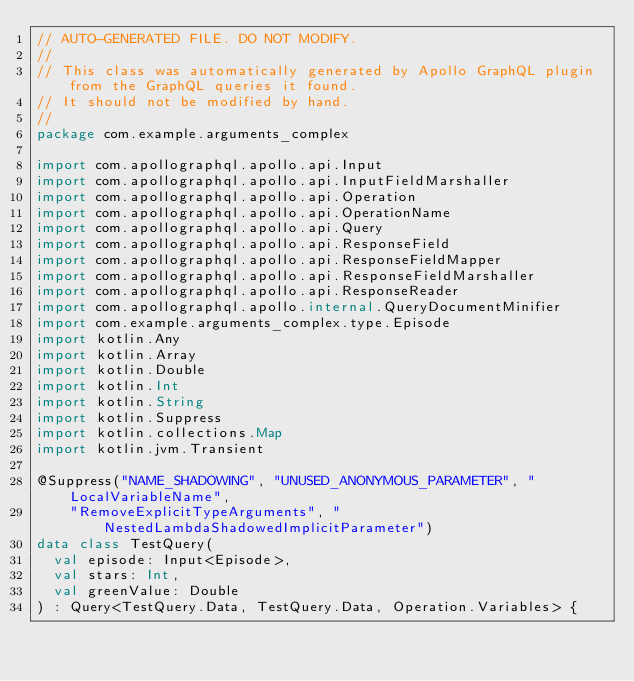Convert code to text. <code><loc_0><loc_0><loc_500><loc_500><_Kotlin_>// AUTO-GENERATED FILE. DO NOT MODIFY.
//
// This class was automatically generated by Apollo GraphQL plugin from the GraphQL queries it found.
// It should not be modified by hand.
//
package com.example.arguments_complex

import com.apollographql.apollo.api.Input
import com.apollographql.apollo.api.InputFieldMarshaller
import com.apollographql.apollo.api.Operation
import com.apollographql.apollo.api.OperationName
import com.apollographql.apollo.api.Query
import com.apollographql.apollo.api.ResponseField
import com.apollographql.apollo.api.ResponseFieldMapper
import com.apollographql.apollo.api.ResponseFieldMarshaller
import com.apollographql.apollo.api.ResponseReader
import com.apollographql.apollo.internal.QueryDocumentMinifier
import com.example.arguments_complex.type.Episode
import kotlin.Any
import kotlin.Array
import kotlin.Double
import kotlin.Int
import kotlin.String
import kotlin.Suppress
import kotlin.collections.Map
import kotlin.jvm.Transient

@Suppress("NAME_SHADOWING", "UNUSED_ANONYMOUS_PARAMETER", "LocalVariableName",
    "RemoveExplicitTypeArguments", "NestedLambdaShadowedImplicitParameter")
data class TestQuery(
  val episode: Input<Episode>,
  val stars: Int,
  val greenValue: Double
) : Query<TestQuery.Data, TestQuery.Data, Operation.Variables> {</code> 